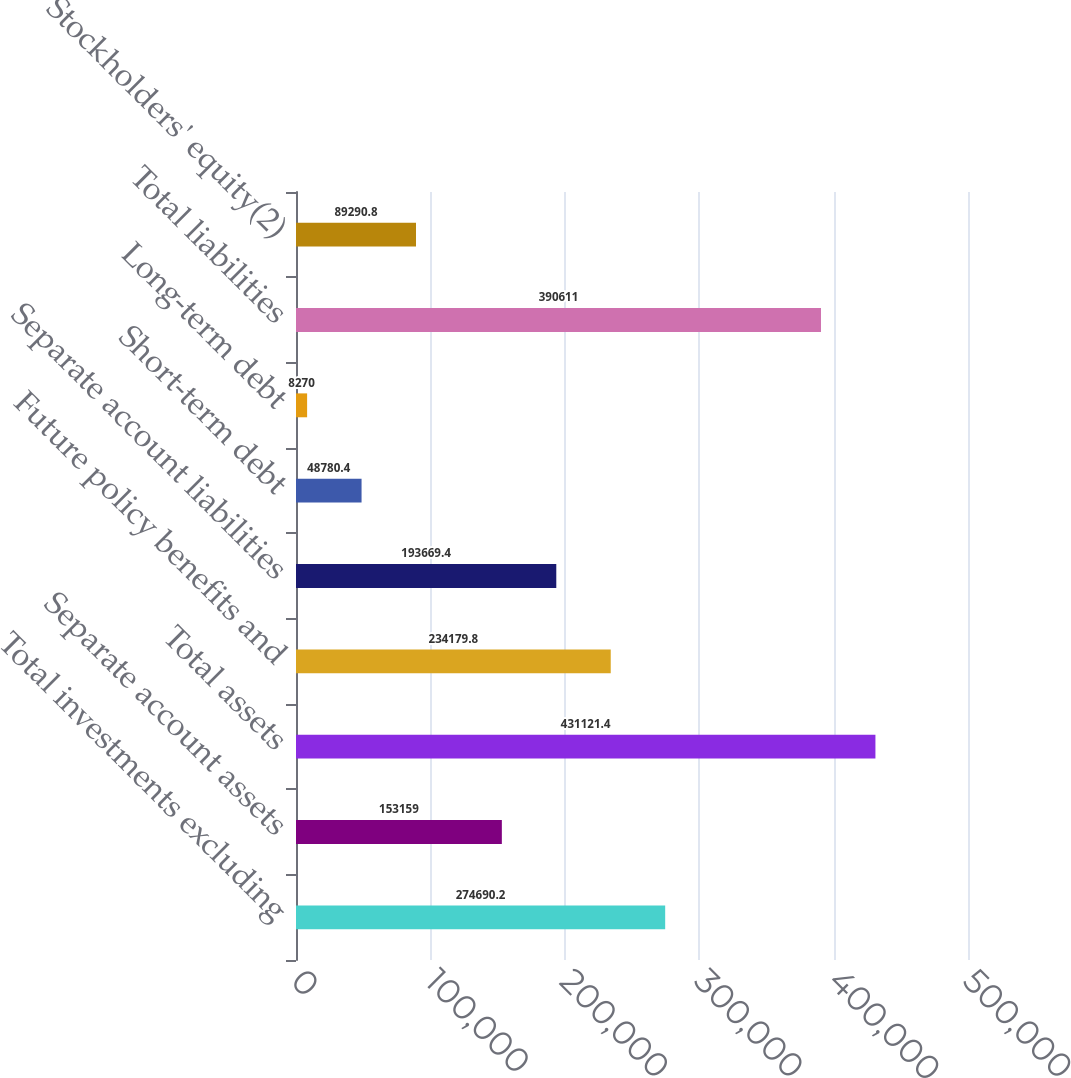Convert chart. <chart><loc_0><loc_0><loc_500><loc_500><bar_chart><fcel>Total investments excluding<fcel>Separate account assets<fcel>Total assets<fcel>Future policy benefits and<fcel>Separate account liabilities<fcel>Short-term debt<fcel>Long-term debt<fcel>Total liabilities<fcel>Stockholders' equity(2)<nl><fcel>274690<fcel>153159<fcel>431121<fcel>234180<fcel>193669<fcel>48780.4<fcel>8270<fcel>390611<fcel>89290.8<nl></chart> 